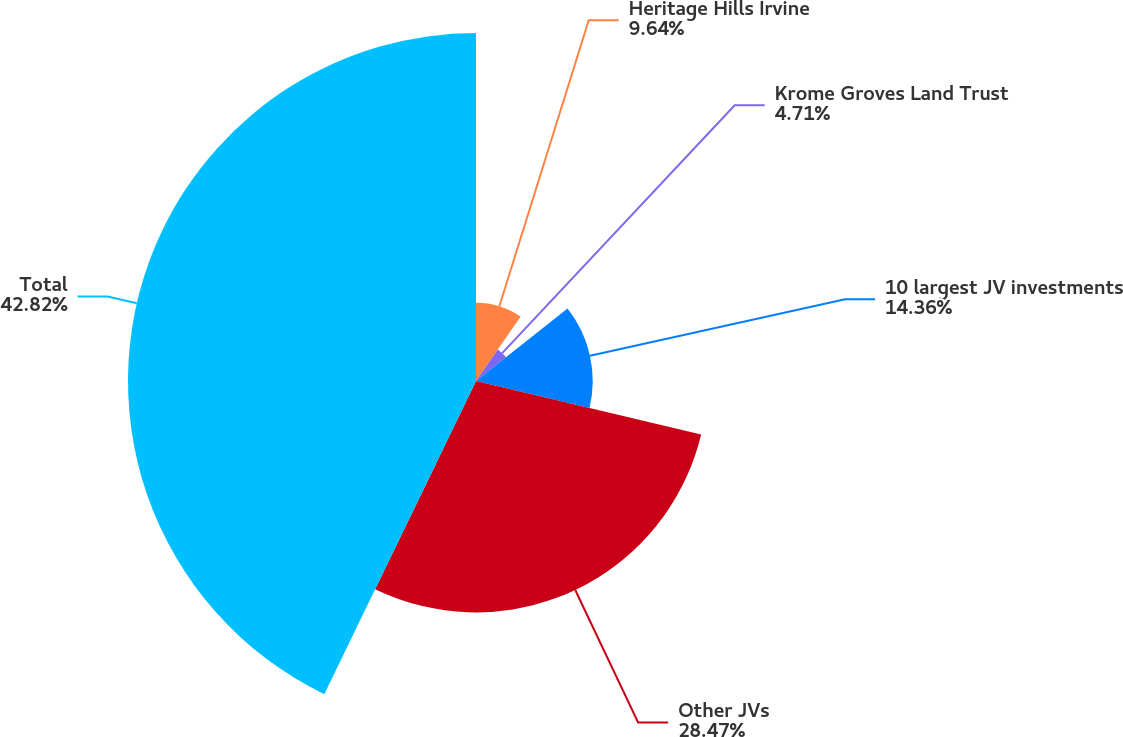Convert chart. <chart><loc_0><loc_0><loc_500><loc_500><pie_chart><fcel>Heritage Hills Irvine<fcel>Krome Groves Land Trust<fcel>10 largest JV investments<fcel>Other JVs<fcel>Total<nl><fcel>9.64%<fcel>4.71%<fcel>14.36%<fcel>28.47%<fcel>42.82%<nl></chart> 